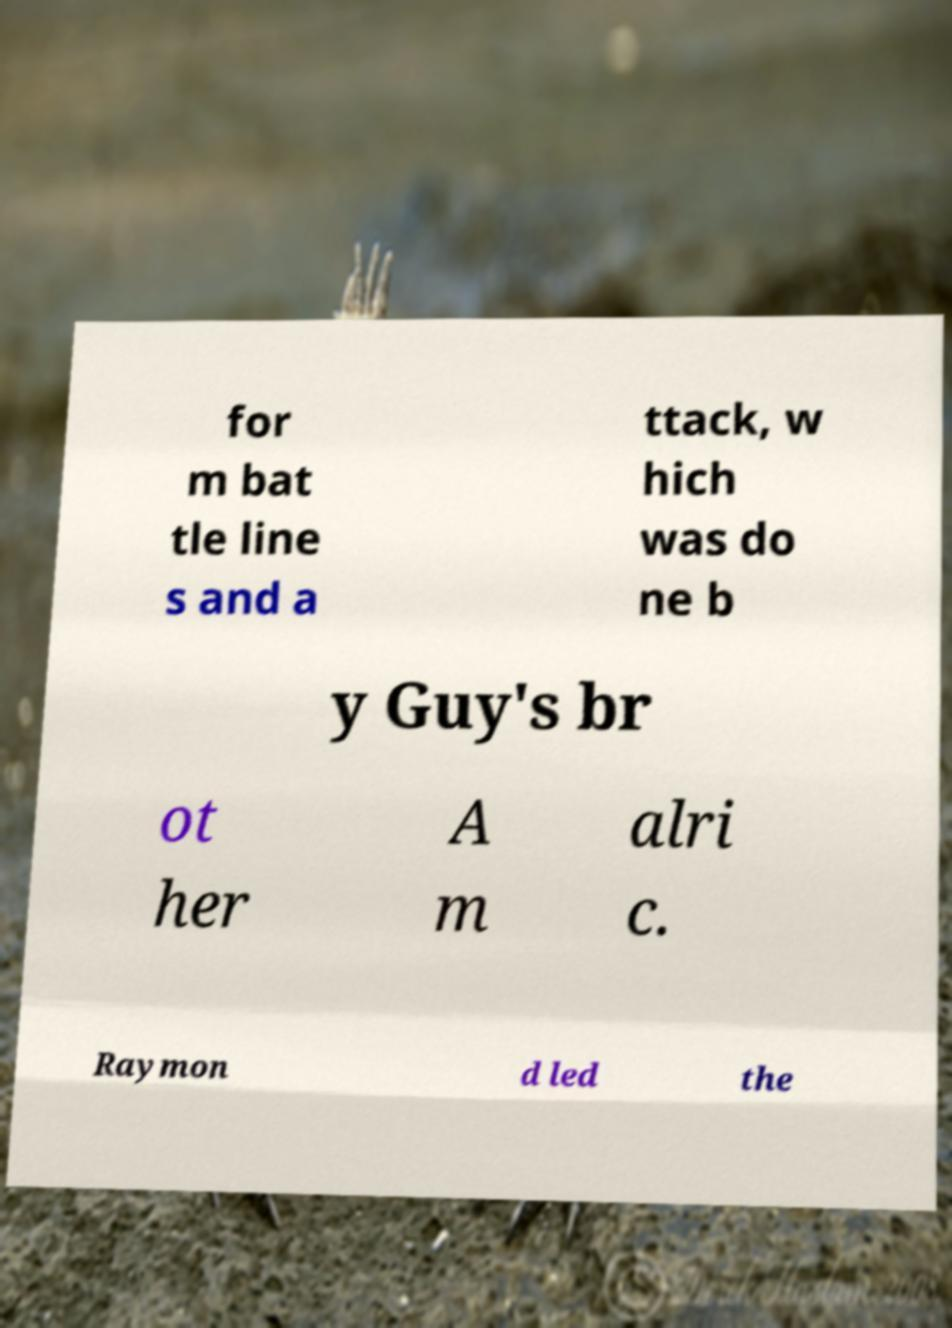Can you read and provide the text displayed in the image?This photo seems to have some interesting text. Can you extract and type it out for me? for m bat tle line s and a ttack, w hich was do ne b y Guy's br ot her A m alri c. Raymon d led the 